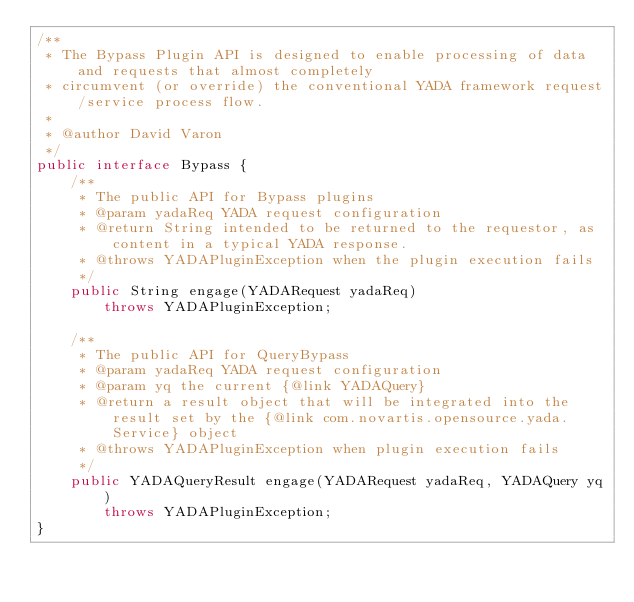Convert code to text. <code><loc_0><loc_0><loc_500><loc_500><_Java_>/**
 * The Bypass Plugin API is designed to enable processing of data and requests that almost completely 
 * circumvent (or override) the conventional YADA framework request/service process flow.
 * 
 * @author David Varon
 */
public interface Bypass {
	/**
	 * The public API for Bypass plugins
	 * @param yadaReq YADA request configuration
	 * @return String intended to be returned to the requestor, as content in a typical YADA response. 
	 * @throws YADAPluginException when the plugin execution fails
	 */
	public String engage(YADARequest yadaReq)
		throws YADAPluginException;
	
	/**
	 * The public API for QueryBypass
	 * @param yadaReq YADA request configuration
	 * @param yq the current {@link YADAQuery}
	 * @return a result object that will be integrated into the result set by the {@link com.novartis.opensource.yada.Service} object
	 * @throws YADAPluginException when plugin execution fails
	 */
	public YADAQueryResult engage(YADARequest yadaReq, YADAQuery yq)
	    throws YADAPluginException;
}
</code> 